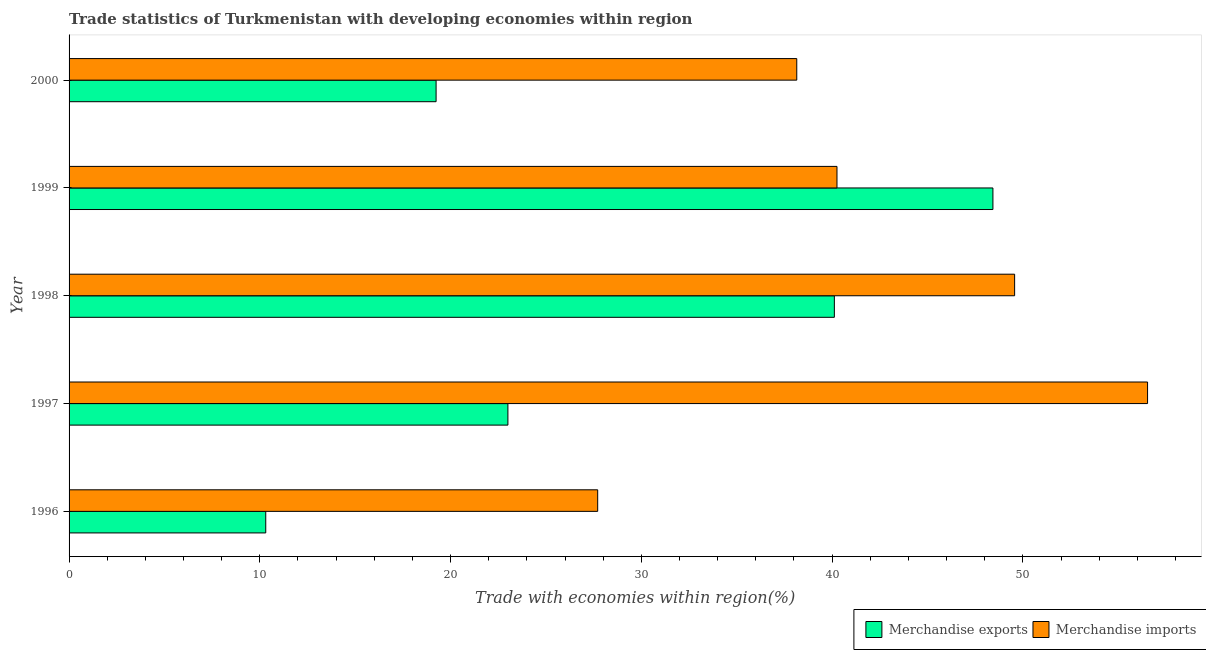How many different coloured bars are there?
Your response must be concise. 2. Are the number of bars per tick equal to the number of legend labels?
Give a very brief answer. Yes. Are the number of bars on each tick of the Y-axis equal?
Offer a terse response. Yes. How many bars are there on the 2nd tick from the top?
Your response must be concise. 2. How many bars are there on the 3rd tick from the bottom?
Your answer should be very brief. 2. What is the label of the 4th group of bars from the top?
Keep it short and to the point. 1997. In how many cases, is the number of bars for a given year not equal to the number of legend labels?
Your response must be concise. 0. What is the merchandise imports in 1997?
Provide a short and direct response. 56.54. Across all years, what is the maximum merchandise exports?
Your answer should be compact. 48.43. Across all years, what is the minimum merchandise imports?
Offer a very short reply. 27.71. In which year was the merchandise imports maximum?
Offer a very short reply. 1997. What is the total merchandise exports in the graph?
Make the answer very short. 141.1. What is the difference between the merchandise exports in 1997 and that in 1998?
Provide a short and direct response. -17.11. What is the difference between the merchandise imports in 2000 and the merchandise exports in 1996?
Provide a succinct answer. 27.84. What is the average merchandise exports per year?
Keep it short and to the point. 28.22. In the year 1999, what is the difference between the merchandise exports and merchandise imports?
Offer a terse response. 8.18. What is the ratio of the merchandise exports in 1997 to that in 2000?
Your answer should be very brief. 1.2. Is the difference between the merchandise exports in 1996 and 1998 greater than the difference between the merchandise imports in 1996 and 1998?
Ensure brevity in your answer.  No. What is the difference between the highest and the second highest merchandise exports?
Provide a short and direct response. 8.31. What is the difference between the highest and the lowest merchandise exports?
Make the answer very short. 38.12. In how many years, is the merchandise imports greater than the average merchandise imports taken over all years?
Offer a terse response. 2. What does the 2nd bar from the top in 1996 represents?
Make the answer very short. Merchandise exports. What does the 1st bar from the bottom in 1999 represents?
Give a very brief answer. Merchandise exports. How many bars are there?
Offer a very short reply. 10. How many legend labels are there?
Give a very brief answer. 2. How are the legend labels stacked?
Give a very brief answer. Horizontal. What is the title of the graph?
Offer a very short reply. Trade statistics of Turkmenistan with developing economies within region. What is the label or title of the X-axis?
Offer a very short reply. Trade with economies within region(%). What is the label or title of the Y-axis?
Keep it short and to the point. Year. What is the Trade with economies within region(%) in Merchandise exports in 1996?
Provide a succinct answer. 10.31. What is the Trade with economies within region(%) in Merchandise imports in 1996?
Give a very brief answer. 27.71. What is the Trade with economies within region(%) of Merchandise exports in 1997?
Provide a succinct answer. 23. What is the Trade with economies within region(%) in Merchandise imports in 1997?
Your response must be concise. 56.54. What is the Trade with economies within region(%) of Merchandise exports in 1998?
Give a very brief answer. 40.12. What is the Trade with economies within region(%) of Merchandise imports in 1998?
Your answer should be very brief. 49.57. What is the Trade with economies within region(%) of Merchandise exports in 1999?
Your answer should be compact. 48.43. What is the Trade with economies within region(%) of Merchandise imports in 1999?
Your response must be concise. 40.26. What is the Trade with economies within region(%) in Merchandise exports in 2000?
Offer a very short reply. 19.24. What is the Trade with economies within region(%) in Merchandise imports in 2000?
Provide a short and direct response. 38.15. Across all years, what is the maximum Trade with economies within region(%) in Merchandise exports?
Your answer should be very brief. 48.43. Across all years, what is the maximum Trade with economies within region(%) of Merchandise imports?
Provide a short and direct response. 56.54. Across all years, what is the minimum Trade with economies within region(%) of Merchandise exports?
Ensure brevity in your answer.  10.31. Across all years, what is the minimum Trade with economies within region(%) of Merchandise imports?
Offer a very short reply. 27.71. What is the total Trade with economies within region(%) in Merchandise exports in the graph?
Offer a very short reply. 141.1. What is the total Trade with economies within region(%) of Merchandise imports in the graph?
Keep it short and to the point. 212.22. What is the difference between the Trade with economies within region(%) in Merchandise exports in 1996 and that in 1997?
Keep it short and to the point. -12.69. What is the difference between the Trade with economies within region(%) of Merchandise imports in 1996 and that in 1997?
Your answer should be compact. -28.83. What is the difference between the Trade with economies within region(%) of Merchandise exports in 1996 and that in 1998?
Offer a terse response. -29.81. What is the difference between the Trade with economies within region(%) of Merchandise imports in 1996 and that in 1998?
Ensure brevity in your answer.  -21.86. What is the difference between the Trade with economies within region(%) of Merchandise exports in 1996 and that in 1999?
Make the answer very short. -38.12. What is the difference between the Trade with economies within region(%) in Merchandise imports in 1996 and that in 1999?
Provide a succinct answer. -12.54. What is the difference between the Trade with economies within region(%) of Merchandise exports in 1996 and that in 2000?
Your response must be concise. -8.93. What is the difference between the Trade with economies within region(%) of Merchandise imports in 1996 and that in 2000?
Ensure brevity in your answer.  -10.44. What is the difference between the Trade with economies within region(%) of Merchandise exports in 1997 and that in 1998?
Offer a terse response. -17.11. What is the difference between the Trade with economies within region(%) in Merchandise imports in 1997 and that in 1998?
Offer a terse response. 6.97. What is the difference between the Trade with economies within region(%) in Merchandise exports in 1997 and that in 1999?
Your answer should be compact. -25.43. What is the difference between the Trade with economies within region(%) in Merchandise imports in 1997 and that in 1999?
Your answer should be compact. 16.28. What is the difference between the Trade with economies within region(%) in Merchandise exports in 1997 and that in 2000?
Ensure brevity in your answer.  3.76. What is the difference between the Trade with economies within region(%) of Merchandise imports in 1997 and that in 2000?
Give a very brief answer. 18.39. What is the difference between the Trade with economies within region(%) in Merchandise exports in 1998 and that in 1999?
Provide a succinct answer. -8.31. What is the difference between the Trade with economies within region(%) of Merchandise imports in 1998 and that in 1999?
Offer a very short reply. 9.31. What is the difference between the Trade with economies within region(%) in Merchandise exports in 1998 and that in 2000?
Offer a very short reply. 20.88. What is the difference between the Trade with economies within region(%) of Merchandise imports in 1998 and that in 2000?
Give a very brief answer. 11.42. What is the difference between the Trade with economies within region(%) of Merchandise exports in 1999 and that in 2000?
Your answer should be very brief. 29.19. What is the difference between the Trade with economies within region(%) in Merchandise imports in 1999 and that in 2000?
Your response must be concise. 2.11. What is the difference between the Trade with economies within region(%) in Merchandise exports in 1996 and the Trade with economies within region(%) in Merchandise imports in 1997?
Ensure brevity in your answer.  -46.23. What is the difference between the Trade with economies within region(%) in Merchandise exports in 1996 and the Trade with economies within region(%) in Merchandise imports in 1998?
Offer a very short reply. -39.26. What is the difference between the Trade with economies within region(%) of Merchandise exports in 1996 and the Trade with economies within region(%) of Merchandise imports in 1999?
Keep it short and to the point. -29.95. What is the difference between the Trade with economies within region(%) in Merchandise exports in 1996 and the Trade with economies within region(%) in Merchandise imports in 2000?
Keep it short and to the point. -27.84. What is the difference between the Trade with economies within region(%) of Merchandise exports in 1997 and the Trade with economies within region(%) of Merchandise imports in 1998?
Offer a terse response. -26.56. What is the difference between the Trade with economies within region(%) of Merchandise exports in 1997 and the Trade with economies within region(%) of Merchandise imports in 1999?
Your answer should be very brief. -17.25. What is the difference between the Trade with economies within region(%) in Merchandise exports in 1997 and the Trade with economies within region(%) in Merchandise imports in 2000?
Provide a short and direct response. -15.14. What is the difference between the Trade with economies within region(%) in Merchandise exports in 1998 and the Trade with economies within region(%) in Merchandise imports in 1999?
Offer a very short reply. -0.14. What is the difference between the Trade with economies within region(%) of Merchandise exports in 1998 and the Trade with economies within region(%) of Merchandise imports in 2000?
Make the answer very short. 1.97. What is the difference between the Trade with economies within region(%) of Merchandise exports in 1999 and the Trade with economies within region(%) of Merchandise imports in 2000?
Keep it short and to the point. 10.28. What is the average Trade with economies within region(%) in Merchandise exports per year?
Offer a terse response. 28.22. What is the average Trade with economies within region(%) of Merchandise imports per year?
Provide a short and direct response. 42.44. In the year 1996, what is the difference between the Trade with economies within region(%) in Merchandise exports and Trade with economies within region(%) in Merchandise imports?
Keep it short and to the point. -17.4. In the year 1997, what is the difference between the Trade with economies within region(%) of Merchandise exports and Trade with economies within region(%) of Merchandise imports?
Ensure brevity in your answer.  -33.53. In the year 1998, what is the difference between the Trade with economies within region(%) in Merchandise exports and Trade with economies within region(%) in Merchandise imports?
Give a very brief answer. -9.45. In the year 1999, what is the difference between the Trade with economies within region(%) in Merchandise exports and Trade with economies within region(%) in Merchandise imports?
Offer a terse response. 8.17. In the year 2000, what is the difference between the Trade with economies within region(%) in Merchandise exports and Trade with economies within region(%) in Merchandise imports?
Provide a short and direct response. -18.91. What is the ratio of the Trade with economies within region(%) in Merchandise exports in 1996 to that in 1997?
Ensure brevity in your answer.  0.45. What is the ratio of the Trade with economies within region(%) of Merchandise imports in 1996 to that in 1997?
Offer a very short reply. 0.49. What is the ratio of the Trade with economies within region(%) in Merchandise exports in 1996 to that in 1998?
Make the answer very short. 0.26. What is the ratio of the Trade with economies within region(%) of Merchandise imports in 1996 to that in 1998?
Ensure brevity in your answer.  0.56. What is the ratio of the Trade with economies within region(%) of Merchandise exports in 1996 to that in 1999?
Offer a very short reply. 0.21. What is the ratio of the Trade with economies within region(%) in Merchandise imports in 1996 to that in 1999?
Make the answer very short. 0.69. What is the ratio of the Trade with economies within region(%) in Merchandise exports in 1996 to that in 2000?
Offer a terse response. 0.54. What is the ratio of the Trade with economies within region(%) in Merchandise imports in 1996 to that in 2000?
Provide a short and direct response. 0.73. What is the ratio of the Trade with economies within region(%) in Merchandise exports in 1997 to that in 1998?
Make the answer very short. 0.57. What is the ratio of the Trade with economies within region(%) of Merchandise imports in 1997 to that in 1998?
Keep it short and to the point. 1.14. What is the ratio of the Trade with economies within region(%) of Merchandise exports in 1997 to that in 1999?
Offer a terse response. 0.47. What is the ratio of the Trade with economies within region(%) in Merchandise imports in 1997 to that in 1999?
Your response must be concise. 1.4. What is the ratio of the Trade with economies within region(%) of Merchandise exports in 1997 to that in 2000?
Offer a terse response. 1.2. What is the ratio of the Trade with economies within region(%) in Merchandise imports in 1997 to that in 2000?
Your answer should be very brief. 1.48. What is the ratio of the Trade with economies within region(%) of Merchandise exports in 1998 to that in 1999?
Give a very brief answer. 0.83. What is the ratio of the Trade with economies within region(%) in Merchandise imports in 1998 to that in 1999?
Offer a very short reply. 1.23. What is the ratio of the Trade with economies within region(%) in Merchandise exports in 1998 to that in 2000?
Your response must be concise. 2.09. What is the ratio of the Trade with economies within region(%) in Merchandise imports in 1998 to that in 2000?
Give a very brief answer. 1.3. What is the ratio of the Trade with economies within region(%) in Merchandise exports in 1999 to that in 2000?
Ensure brevity in your answer.  2.52. What is the ratio of the Trade with economies within region(%) in Merchandise imports in 1999 to that in 2000?
Your answer should be compact. 1.06. What is the difference between the highest and the second highest Trade with economies within region(%) of Merchandise exports?
Offer a very short reply. 8.31. What is the difference between the highest and the second highest Trade with economies within region(%) of Merchandise imports?
Offer a terse response. 6.97. What is the difference between the highest and the lowest Trade with economies within region(%) in Merchandise exports?
Provide a succinct answer. 38.12. What is the difference between the highest and the lowest Trade with economies within region(%) of Merchandise imports?
Your response must be concise. 28.83. 